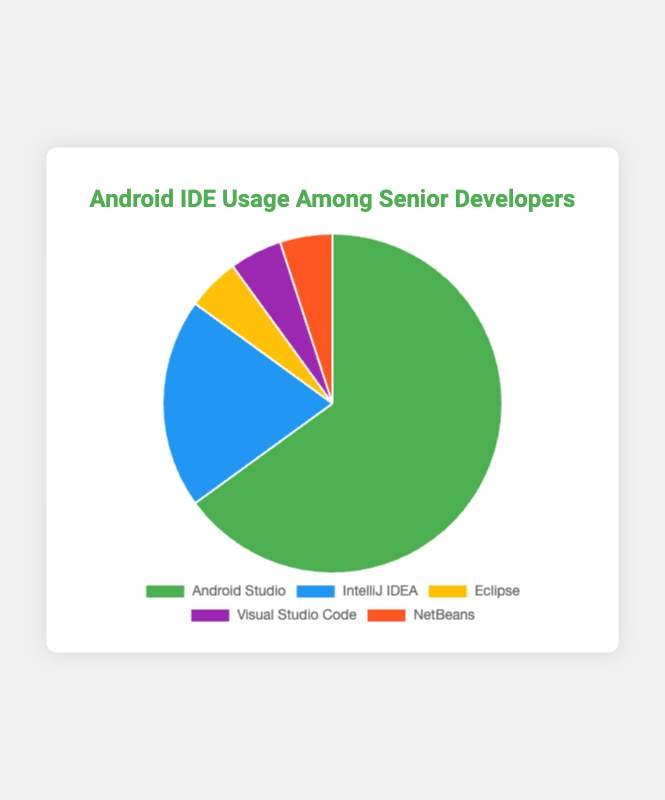What percentage of senior developers use Android Studio compared to those who use IntelliJ IDEA? Android Studio is used by 65% of senior developers, while IntelliJ IDEA is used by 20%. Comparing these two percentages, Android Studio is used by a greater percentage of developers.
Answer: Android Studio (65%) is higher What is the combined percentage of senior developers who use either Eclipse, Visual Studio Code, or NetBeans? Eclipse, Visual Studio Code, and NetBeans each account for 5% usage. Summing these up, the combined percentage is 5% + 5% + 5% = 15%.
Answer: 15% Which IDE is the least popular among senior developers? Both Eclipse, Visual Studio Code, and NetBeans are used by only 5% of senior developers, making them the least popular.
Answer: Tie between Eclipse, Visual Studio Code, and NetBeans What is the difference in usage between the most popular and the least popular IDEs among senior developers? The most popular IDE is Android Studio with 65% usage, and the least popular IDES (Eclipse, Visual Studio Code, and NetBeans) each have 5% usage. The difference is 65% - 5% = 60%.
Answer: 60% What color represents the usage data for IntelliJ IDEA in the pie chart? The legend in the pie chart shows that IntelliJ IDEA is represented by the color blue.
Answer: Blue Is the percentage of senior developers using Android Studio higher than the combined percentage of those using other IDEs? Android Studio is used by 65% of senior developers. The combined percentage for other IDEs (20% for IntelliJ IDEA, 5% for Eclipse, 5% for Visual Studio Code, 5% for NetBeans) is 35%. 65% (Android Studio) is higher than 35% (all other IDEs combined).
Answer: Yes, 65% is higher What is the average percentage usage of the four less popular IDEs (IntelliJ IDEA, Eclipse, Visual Studio Code, NetBeans)? The percentages are 20% for IntelliJ IDEA, 5% for Eclipse, 5% for Visual Studio Code, and 5% for NetBeans. Summing these up gives 20% + 5% + 5% + 5% = 35%. There are 4 IDEs, so the average usage is 35% / 4 = 8.75%.
Answer: 8.75% How many more times do senior developers use Android Studio compared to Eclipse? Android Studio has 65% usage, while Eclipse has 5%. The ratio is 65% / 5% = 13. This means Android Studio is used 13 times more than Eclipse.
Answer: 13 times What proportion of the pie chart is represented by usage of Android Studio? Android Studio represents 65% of the total usage, which means it occupies 65% of the pie chart.
Answer: 65% 